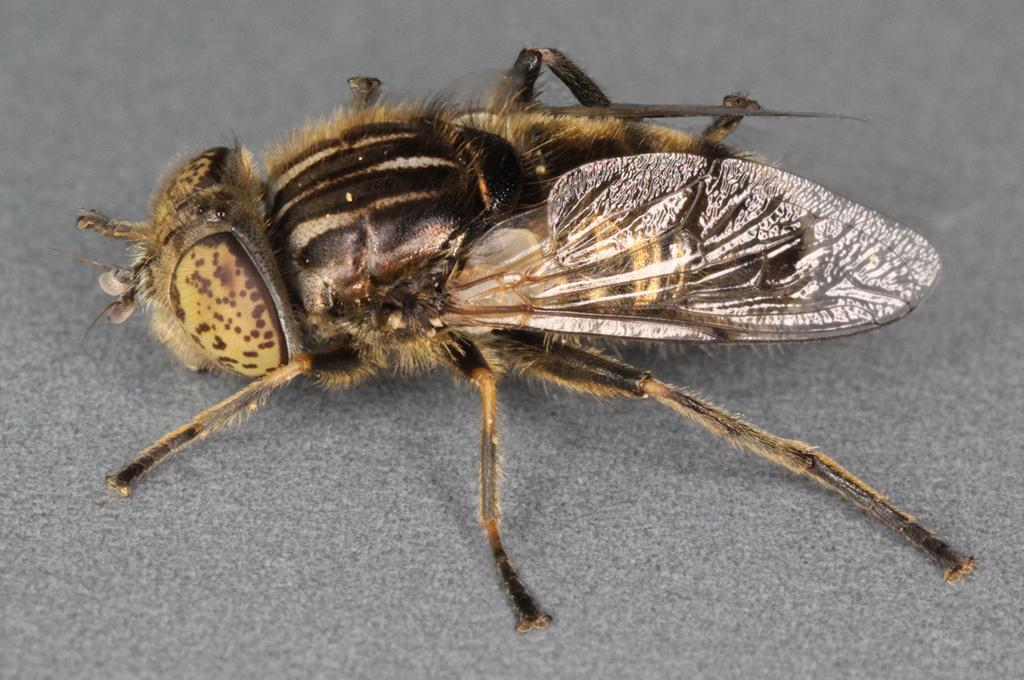What is present on the surface in the center of the image? There is a fly on the surface in the center of the image. How many brothers does the fly have in the image? There is no information about the fly's family in the image, so we cannot determine the number of brothers it has. 